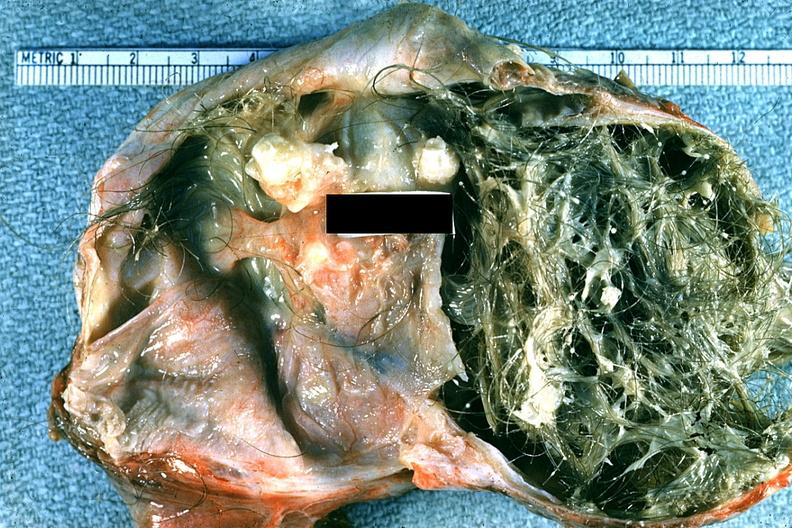how does this image show good example typical dermoid?
Answer the question using a single word or phrase. With hair and sebaceous material 